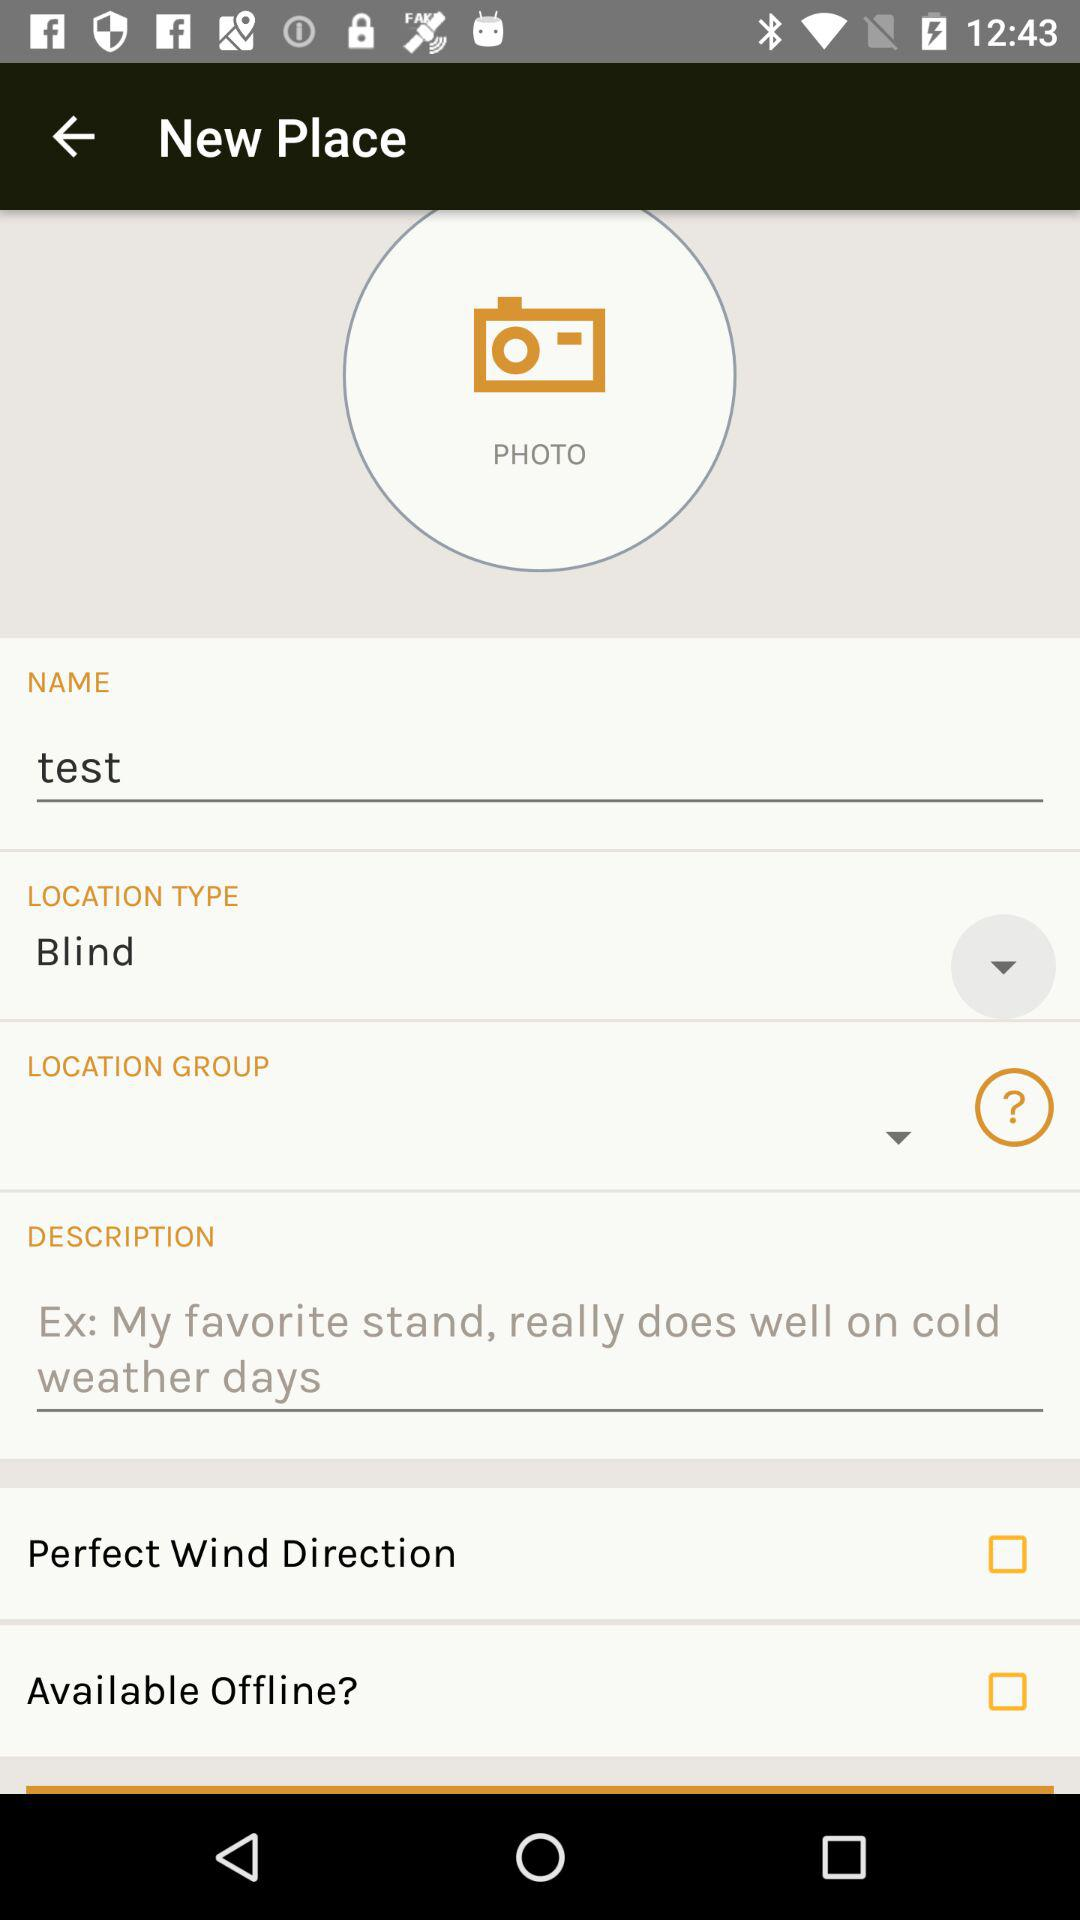What is the name? The name is "test". 